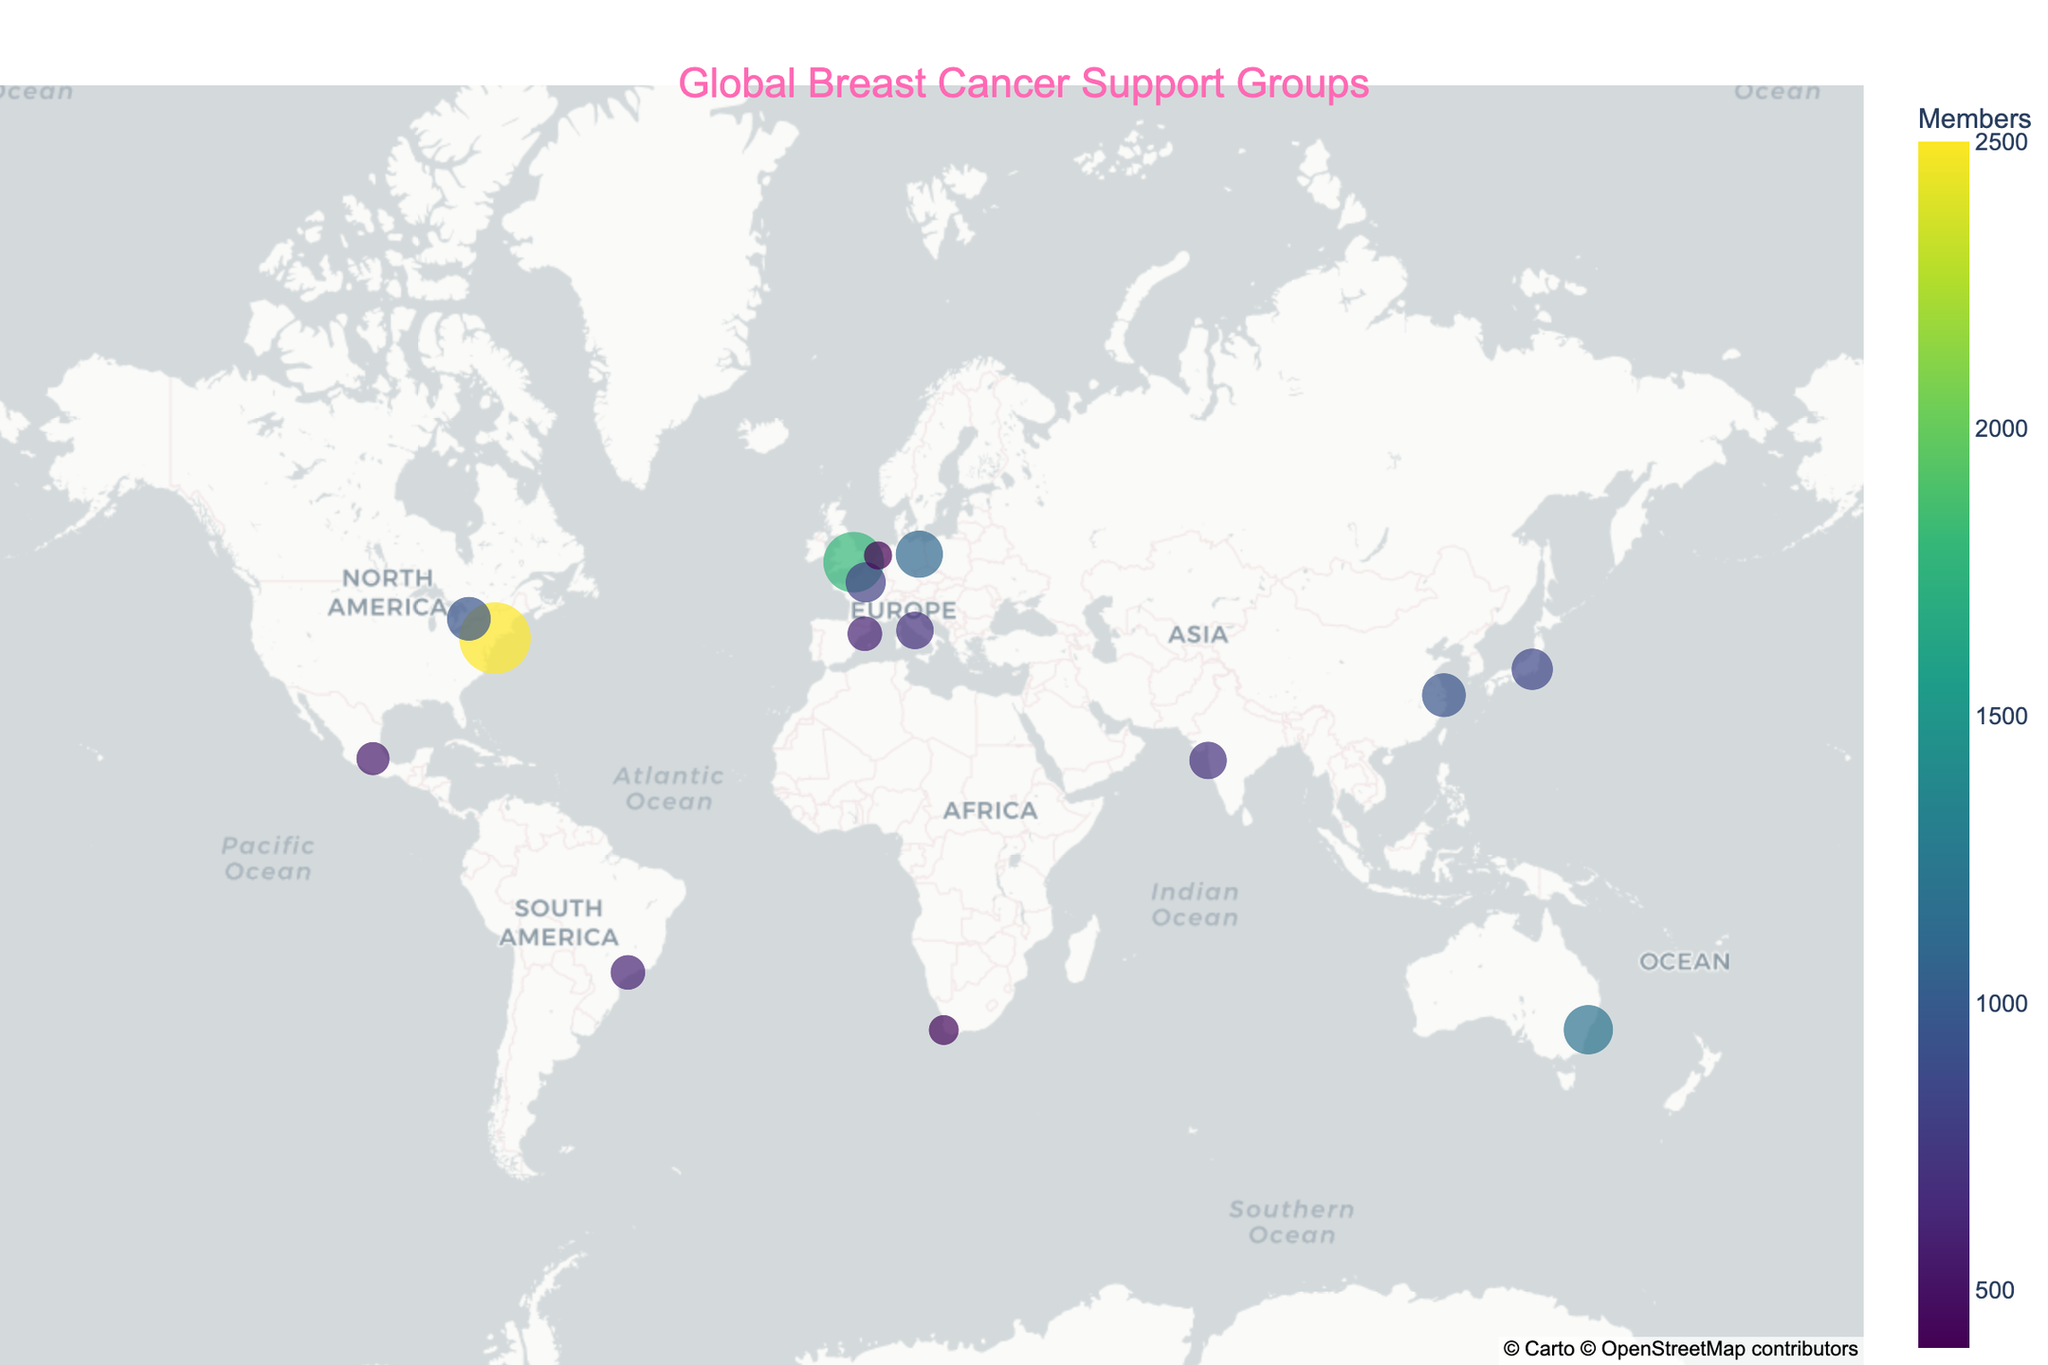Which country has the largest breast cancer support group in terms of members? The largest support group can be identified by the size of the circle representing the organization. In the figure, the largest circle is located in the United States, New York, representing Susan G. Komen NYC with 2500 members.
Answer: United States How many breast cancer support groups are located in Europe? Europe includes the United Kingdom (London), Germany (Berlin), France (Paris), Italy (Rome), Spain (Barcelona), and the Netherlands (Amsterdam). By counting the number of cities represented in Europe, we find 6 support groups.
Answer: 6 Which breast cancer support group has the smallest number of members and where is it located? The smallest support group can be identified by the smallest circle on the map. According to the figure, the smallest circle is in the Netherlands, Amsterdam, for Pink Ribbon Netherlands with 400 members.
Answer: Pink Ribbon Netherlands in Amsterdam Which support group has more members: Rethink Breast Cancer in Toronto or Shanghai Cancer Recovery Club in Shanghai? By comparing the size of the circles and the member counts given in the hover data, Rethink Breast Cancer has 950 members, and Shanghai Cancer Recovery Club has 950 members as well. Since both have the same number of members, they are equal in size.
Answer: They are equal What is the average number of members across all the depicted breast cancer support groups? To calculate the average number of members, sum up all the member counts and divide by the total number of groups, which is 15. Total members = 17000, average = 17000 / 15 ≈ 1133.33
Answer: Approximately 1133 What is the range of members in breast cancer support groups within the dataset? The range is found by subtracting the smallest number of members from the largest. The largest has 2500 members (Susan G. Komen NYC, New York) and the smallest has 400 members (Pink Ribbon Netherlands, Amsterdam). So, the range = 2500 - 400 = 2100.
Answer: 2100 Which continent has the highest number of breast cancer support groups? To determine this, count the number of support groups on each continent. Europe (6), Asia (3), North America (3), South America (1), Africa (1), and Australia (1). Europe has the highest number.
Answer: Europe How does the number of members in Susan G. Komen NYC compare to the total number of members in European breast cancer support groups? Sum the members of all European support groups: Breast Cancer Care UK (1800) + Deutsche Krebshilfe (1100) + Europa Donna France (800) + Susan G. Komen Italia (700) + FECMA (600) + Pink Ribbon Netherlands (400) = 5400. Compare this to 2500 members in Susan G. Komen NYC. Thus, 2500 < 5400.
Answer: Less What is the total number of members in support groups in the Southern Hemisphere? Southern Hemisphere countries include Australia (1200 members), Brazil (600 members), and South Africa (450 members). Sum these to get the total: 1200 + 600 + 450 = 2250.
Answer: 2250 Are there any regions without any represented breast cancer support groups in the dataset? Review the map to identify any significant gaps. Notably, there are no groups represented in Russia, Middle East countries, and Mexico only has one group represented. Therefore, Middle East and Russia are significant regions without representation.
Answer: Yes, Middle East and Russia 